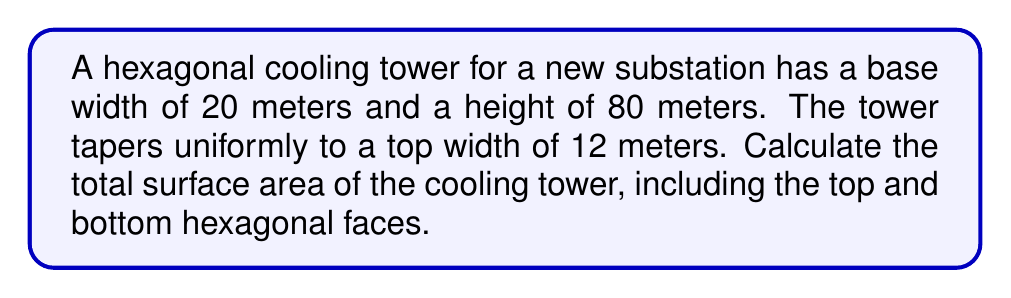Solve this math problem. Let's approach this step-by-step:

1) First, we need to calculate the area of the top and bottom hexagons:
   Area of a regular hexagon = $\frac{3\sqrt{3}}{2}s^2$, where s is the side length
   
   For the bottom: $s = \frac{20}{2} = 10$ m
   Bottom area = $\frac{3\sqrt{3}}{2}(10)^2 = 259.81$ m²
   
   For the top: $s = \frac{12}{2} = 6$ m
   Top area = $\frac{3\sqrt{3}}{2}(6)^2 = 93.53$ m²

2) Now, we need to calculate the lateral surface area. The tower is made up of 6 trapezoidal faces.

3) To find the area of one trapezoidal face, we need its slant height:
   Let x be the horizontal distance the edge moves inward.
   $\tan \theta = \frac{x}{80} = \frac{4}{80} = 0.05$
   $x = 4$ m

   Slant height = $\sqrt{80^2 + 4^2} = 80.1$ m

4) Area of one trapezoidal face:
   $A = \frac{1}{2}(20 + 12) * 80.1 = 1281.6$ m²

5) Total lateral surface area:
   $1281.6 * 6 = 7689.6$ m²

6) Total surface area:
   Top + Bottom + Lateral = $93.53 + 259.81 + 7689.6 = 8042.94$ m²
Answer: $$8042.94 \text{ m}^2$$ 